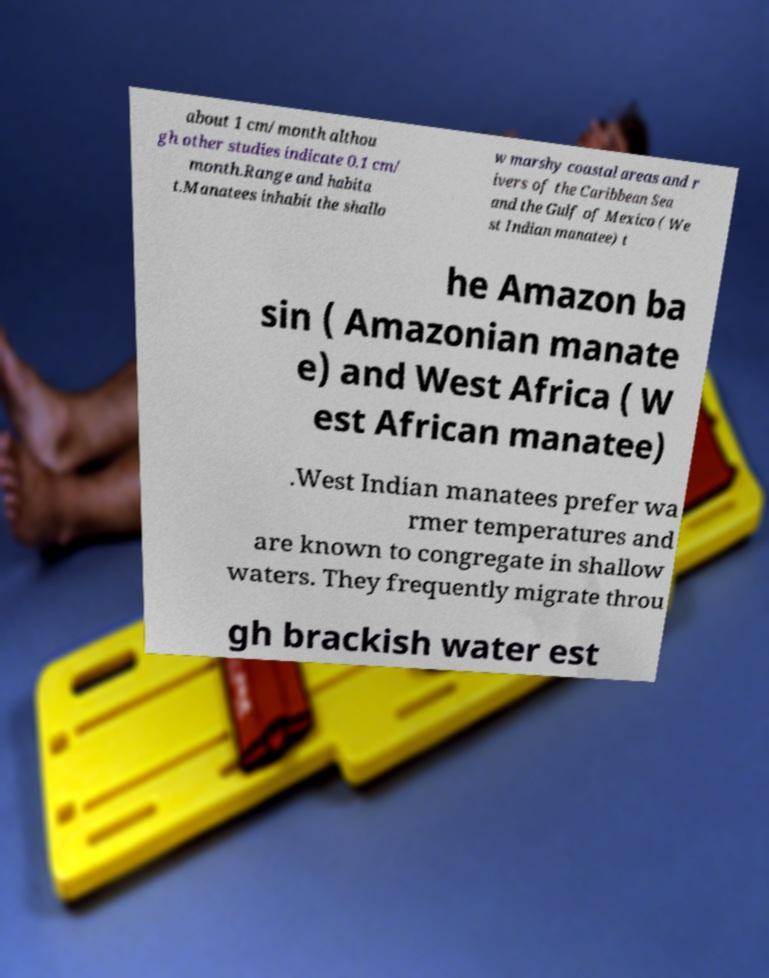What messages or text are displayed in this image? I need them in a readable, typed format. about 1 cm/month althou gh other studies indicate 0.1 cm/ month.Range and habita t.Manatees inhabit the shallo w marshy coastal areas and r ivers of the Caribbean Sea and the Gulf of Mexico ( We st Indian manatee) t he Amazon ba sin ( Amazonian manate e) and West Africa ( W est African manatee) .West Indian manatees prefer wa rmer temperatures and are known to congregate in shallow waters. They frequently migrate throu gh brackish water est 